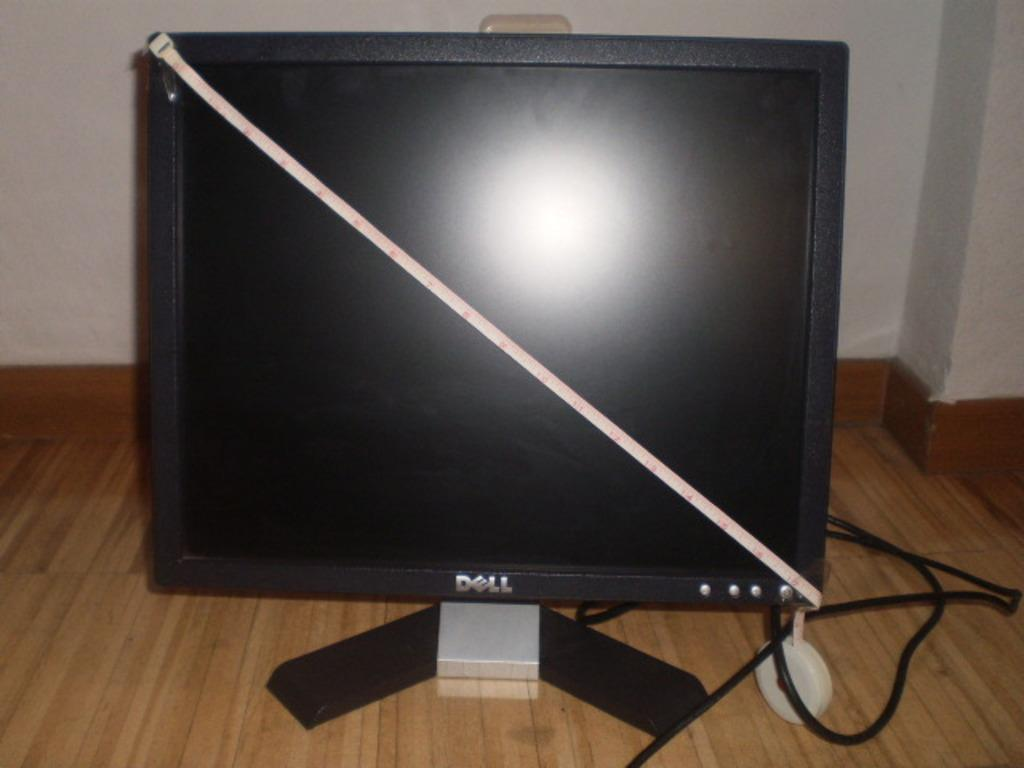Provide a one-sentence caption for the provided image. The flat screen Dell computer is being measured for its actual size. 